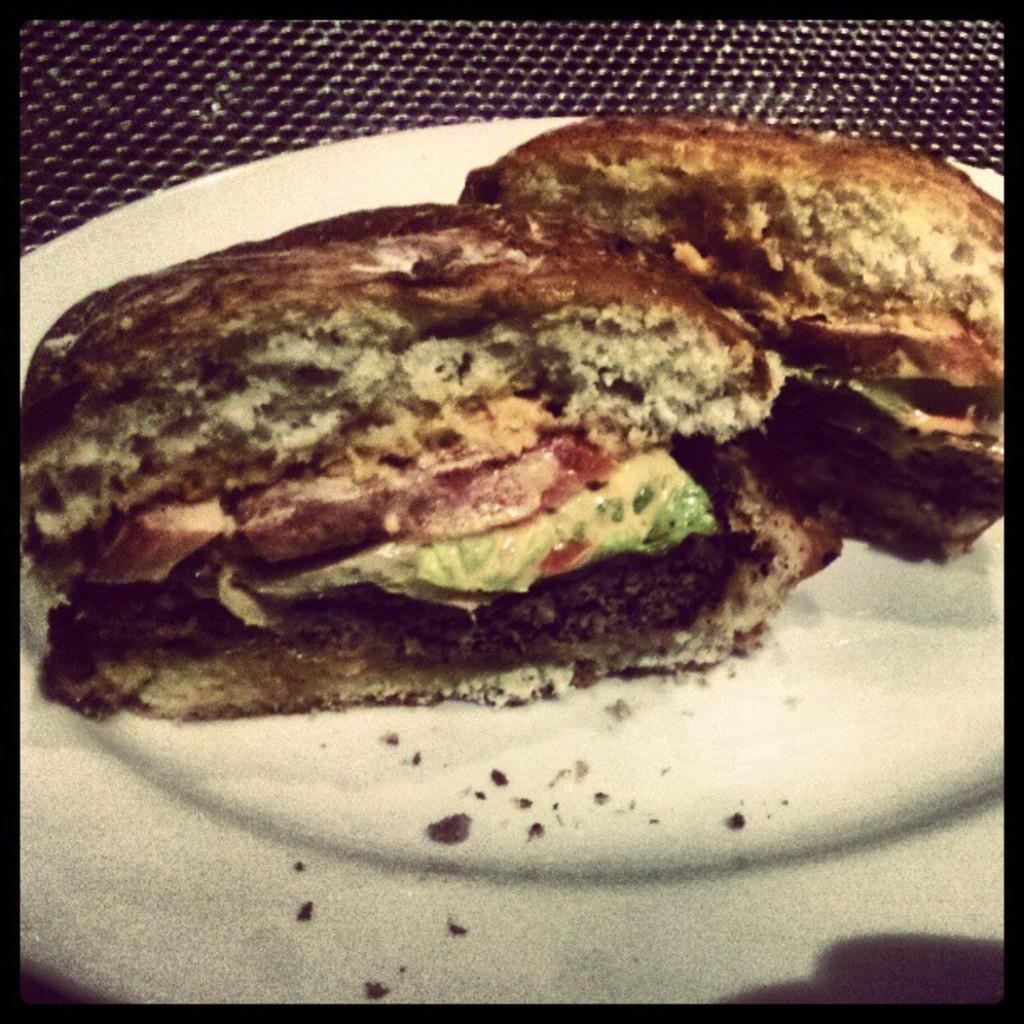Describe this image in one or two sentences. In this picture we can see a plate, there is some food present in this plate. 